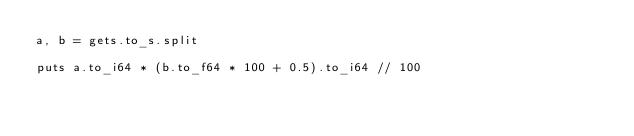Convert code to text. <code><loc_0><loc_0><loc_500><loc_500><_Crystal_>a, b = gets.to_s.split

puts a.to_i64 * (b.to_f64 * 100 + 0.5).to_i64 // 100</code> 